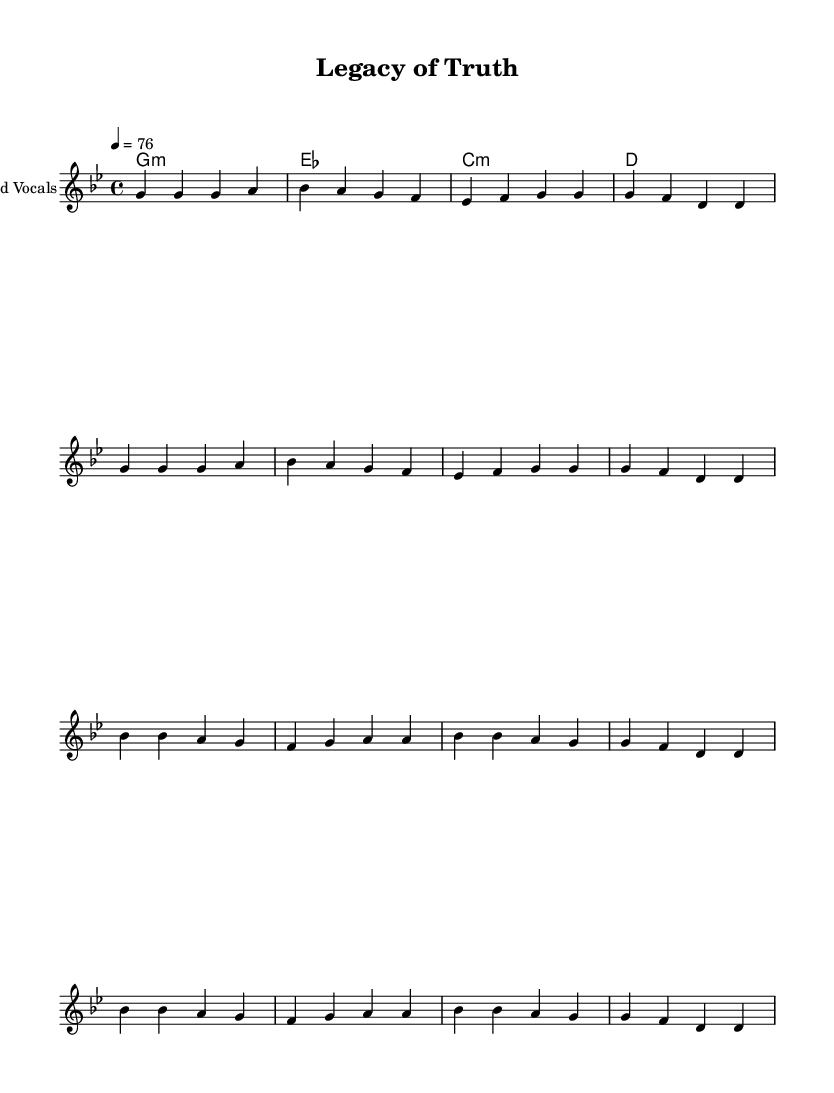What is the key signature of this music? The key signature is G minor, which contains two flats (B♭ and E♭). This can be identified from the key signature indicated at the beginning of the staff lines.
Answer: G minor What is the time signature of this music? The time signature is 4/4, which is commonly known as "common time." It shows that there are four beats in each measure and the quarter note receives one beat.
Answer: 4/4 What is the tempo marking of this music? The tempo marking is 76 beats per minute. This is specified at the beginning of the score with "4 = 76," indicating the pace of the music.
Answer: 76 How many measures are in the verse section? The verse section consists of a repeated pattern of 4 measures each. When counting the measures written in the verse, there are 8 measures in total. This is determined by counting the individual bar lines in the verse part.
Answer: 8 What is the primary theme conveyed in the lyrics? The primary theme in the lyrics focuses on artistic integrity and the legacy of truth. The words emphasize the importance of honesty and representing true values in creative expression. This can be understood by analyzing the meaning of the lyrics, particularly in the chorus.
Answer: Artistic integrity Which chord appears most frequently in the harmonies? The chord that appears most frequently in the harmonies is G minor, which sets the foundational tonality for the song. By examining the chord progression labeled within the score, G minor is the only chord played for an entire measure while others are shorter.
Answer: G minor 